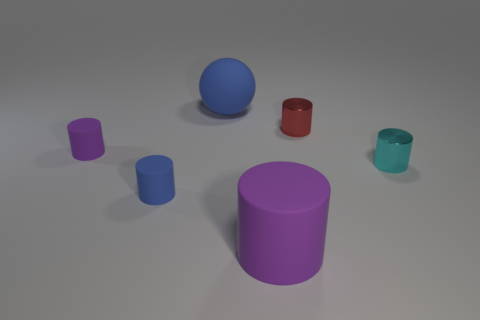Subtract 2 cylinders. How many cylinders are left? 3 Subtract all cyan cylinders. How many cylinders are left? 4 Subtract all small cyan metallic cylinders. How many cylinders are left? 4 Subtract all green cylinders. Subtract all purple cubes. How many cylinders are left? 5 Add 1 green rubber blocks. How many objects exist? 7 Subtract all balls. How many objects are left? 5 Subtract 0 cyan blocks. How many objects are left? 6 Subtract all metal cylinders. Subtract all large rubber cylinders. How many objects are left? 3 Add 5 blue balls. How many blue balls are left? 6 Add 5 cyan rubber cylinders. How many cyan rubber cylinders exist? 5 